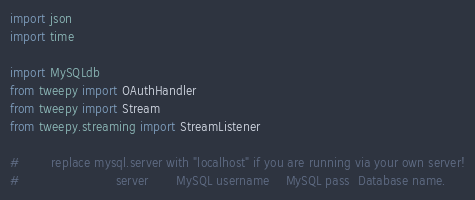<code> <loc_0><loc_0><loc_500><loc_500><_Python_>import json
import time

import MySQLdb
from tweepy import OAuthHandler
from tweepy import Stream
from tweepy.streaming import StreamListener

#        replace mysql.server with "localhost" if you are running via your own server!
#                        server       MySQL username	MySQL pass  Database name.</code> 